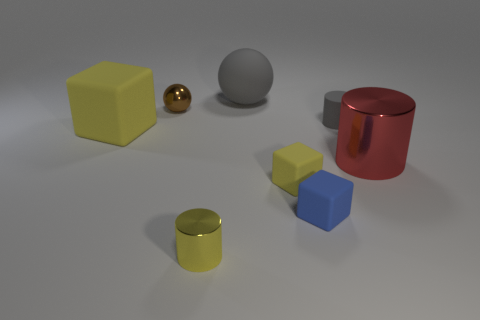Subtract all small blocks. How many blocks are left? 1 Subtract all balls. How many objects are left? 6 Add 1 large red metal things. How many objects exist? 9 Subtract all gray spheres. How many spheres are left? 1 Subtract 1 balls. How many balls are left? 1 Subtract all red objects. Subtract all tiny blue objects. How many objects are left? 6 Add 1 blue objects. How many blue objects are left? 2 Add 5 tiny yellow matte cubes. How many tiny yellow matte cubes exist? 6 Subtract 0 red spheres. How many objects are left? 8 Subtract all gray cylinders. Subtract all blue balls. How many cylinders are left? 2 